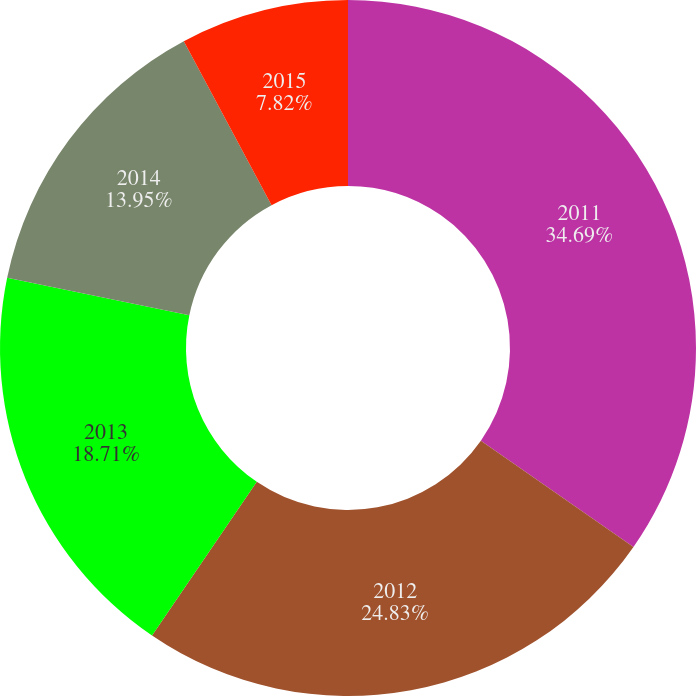<chart> <loc_0><loc_0><loc_500><loc_500><pie_chart><fcel>2011<fcel>2012<fcel>2013<fcel>2014<fcel>2015<nl><fcel>34.69%<fcel>24.83%<fcel>18.71%<fcel>13.95%<fcel>7.82%<nl></chart> 